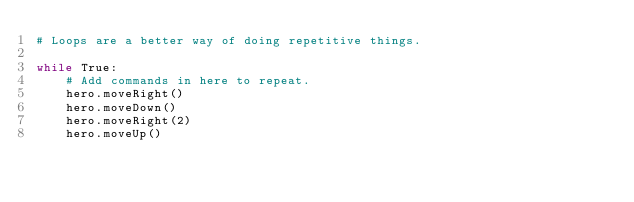Convert code to text. <code><loc_0><loc_0><loc_500><loc_500><_Python_># Loops are a better way of doing repetitive things.

while True:
    # Add commands in here to repeat.
    hero.moveRight()
    hero.moveDown()
    hero.moveRight(2)
    hero.moveUp()
    </code> 